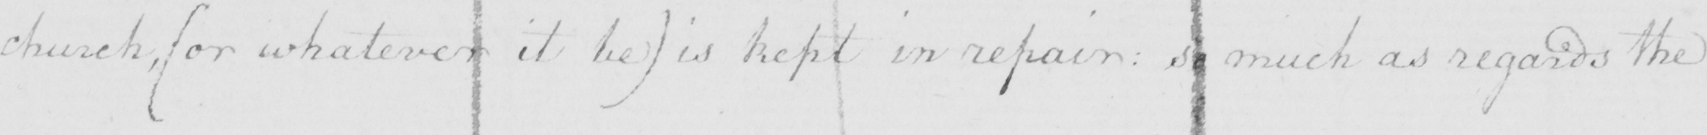Can you read and transcribe this handwriting? church ,  ( or whatever it be )  is kept in repair :  so much as regards the 